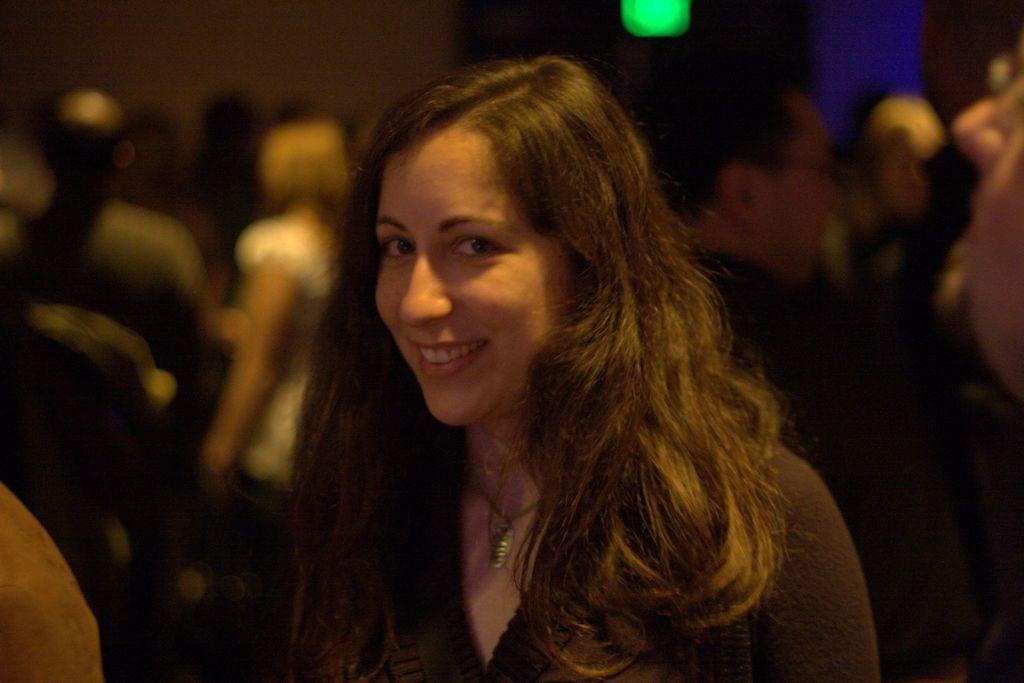What is the main subject of the image? There is a woman standing in the image. Can you describe the people in the background of the image? The people in the background are blurred. What type of fruit can be seen in the hands of the woman in the image? There is no fruit visible in the woman's hands in the image. How many rabbits are present in the image? There are no rabbits present in the image. 